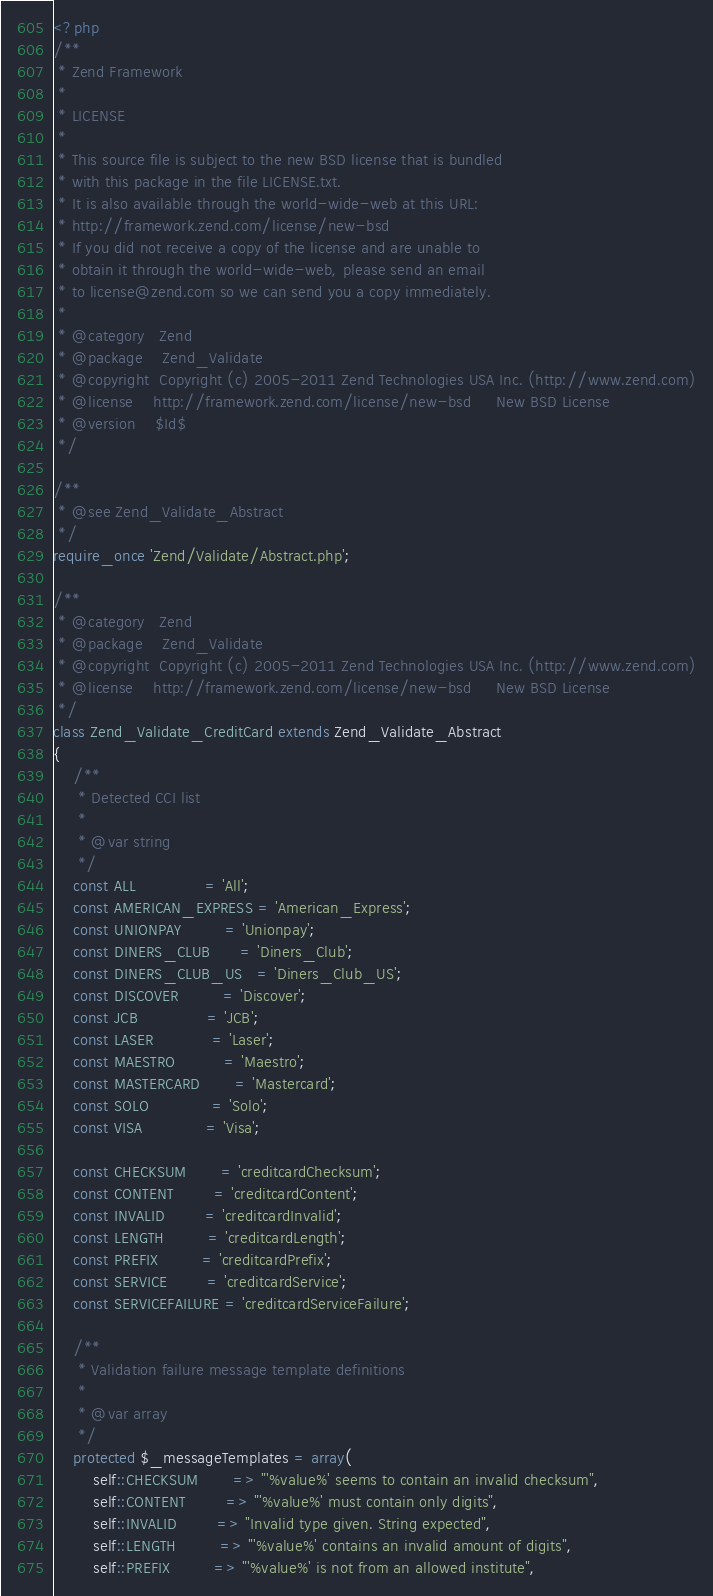<code> <loc_0><loc_0><loc_500><loc_500><_PHP_><?php
/**
 * Zend Framework
 *
 * LICENSE
 *
 * This source file is subject to the new BSD license that is bundled
 * with this package in the file LICENSE.txt.
 * It is also available through the world-wide-web at this URL:
 * http://framework.zend.com/license/new-bsd
 * If you did not receive a copy of the license and are unable to
 * obtain it through the world-wide-web, please send an email
 * to license@zend.com so we can send you a copy immediately.
 *
 * @category   Zend
 * @package    Zend_Validate
 * @copyright  Copyright (c) 2005-2011 Zend Technologies USA Inc. (http://www.zend.com)
 * @license    http://framework.zend.com/license/new-bsd     New BSD License
 * @version    $Id$
 */

/**
 * @see Zend_Validate_Abstract
 */
require_once 'Zend/Validate/Abstract.php';

/**
 * @category   Zend
 * @package    Zend_Validate
 * @copyright  Copyright (c) 2005-2011 Zend Technologies USA Inc. (http://www.zend.com)
 * @license    http://framework.zend.com/license/new-bsd     New BSD License
 */
class Zend_Validate_CreditCard extends Zend_Validate_Abstract
{
    /**
     * Detected CCI list
     *
     * @var string
     */
    const ALL              = 'All';
    const AMERICAN_EXPRESS = 'American_Express';
    const UNIONPAY         = 'Unionpay';
    const DINERS_CLUB      = 'Diners_Club';
    const DINERS_CLUB_US   = 'Diners_Club_US';
    const DISCOVER         = 'Discover';
    const JCB              = 'JCB';
    const LASER            = 'Laser';
    const MAESTRO          = 'Maestro';
    const MASTERCARD       = 'Mastercard';
    const SOLO             = 'Solo';
    const VISA             = 'Visa';

    const CHECKSUM       = 'creditcardChecksum';
    const CONTENT        = 'creditcardContent';
    const INVALID        = 'creditcardInvalid';
    const LENGTH         = 'creditcardLength';
    const PREFIX         = 'creditcardPrefix';
    const SERVICE        = 'creditcardService';
    const SERVICEFAILURE = 'creditcardServiceFailure';

    /**
     * Validation failure message template definitions
     *
     * @var array
     */
    protected $_messageTemplates = array(
        self::CHECKSUM       => "'%value%' seems to contain an invalid checksum",
        self::CONTENT        => "'%value%' must contain only digits",
        self::INVALID        => "Invalid type given. String expected",
        self::LENGTH         => "'%value%' contains an invalid amount of digits",
        self::PREFIX         => "'%value%' is not from an allowed institute",</code> 